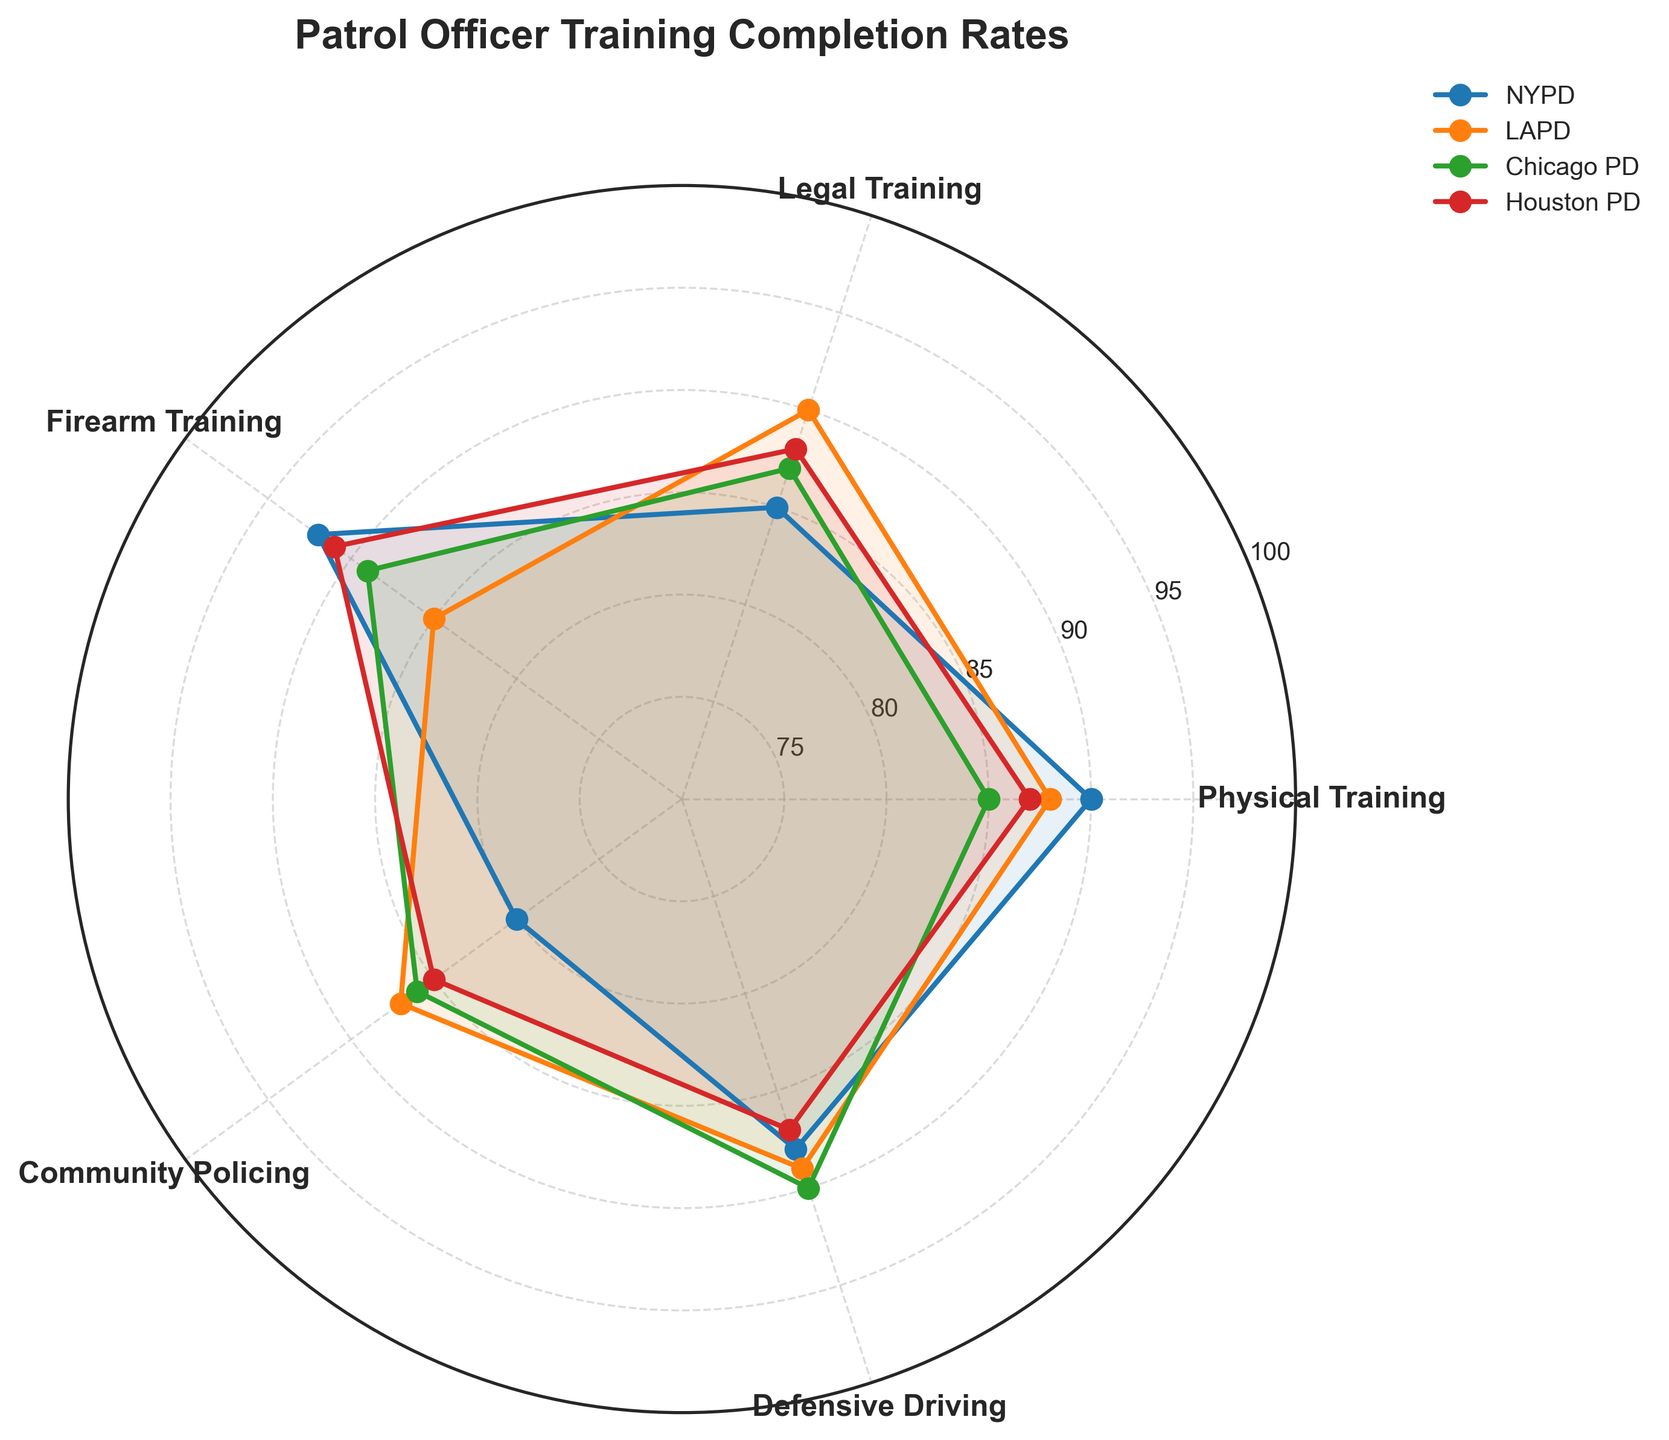What's the title of the radar chart? The title is indicated at the top of the figure.
Answer: Patrol Officer Training Completion Rates How many departments are depicted in the radar chart? The chart has a legend that lists the departments.
Answer: Four Which department has the lowest completion rate for Community Policing training? Compare the Community Policing values from each department. NYPD has 80, while the rest have higher values.
Answer: NYPD Which training category has the highest completion rate across all departments? Look at each training category and identify the highest value. Firearm Training has three values of 91 and one of 92, which is the highest.
Answer: Firearm Training What is the completion rate for Defensive Driving in the LAPD? Refer to the point on the radar chart for LAPD under Defensive Driving.
Answer: 89 How does the NYPD's completion rate in Legal Training compare to the Houston PD's completion rate in the same category? Compare the corresponding values for Legal Training, which are 85 (NYPD) and 88 (Houston PD).
Answer: NYPD is lower What’s the average completion rate of Physical Training across all the departments? Calculate the average of Physical Training values: (90+88+85+87)/4 = 87.5
Answer: 87.5 Which department shows the steadiest training completion rates across all categories (least variation)? Look at the lines for each department and see which one has the flattest or most uniform pattern. LAPD and Houston PD have similar patterns, but Houston PD might be slightly steadier as it avoids any extreme peaks/dips.
Answer: Houston PD In which training category does Chicago PD outperform both NYPD and LAPD? Compare Chicago PD values in each category with NYPD and LAPD. Chicago PD outperforms in Defensive Driving.
Answer: Defensive Driving What's the difference in completion rates for Firearm Training between NYPD and Chicago PD? Subtract the Firearm Training rates: 92 (NYPD) - 89 (Chicago PD) = 3
Answer: 3 